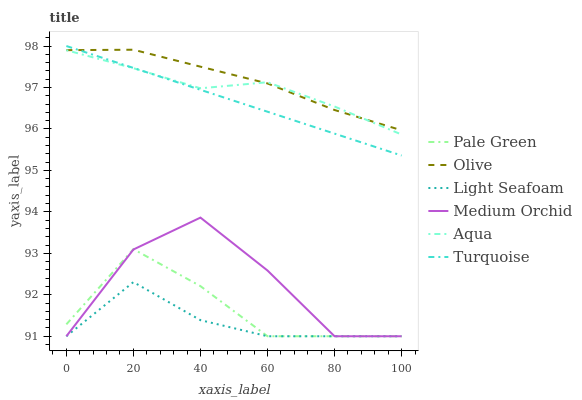Does Medium Orchid have the minimum area under the curve?
Answer yes or no. No. Does Medium Orchid have the maximum area under the curve?
Answer yes or no. No. Is Aqua the smoothest?
Answer yes or no. No. Is Aqua the roughest?
Answer yes or no. No. Does Aqua have the lowest value?
Answer yes or no. No. Does Medium Orchid have the highest value?
Answer yes or no. No. Is Pale Green less than Turquoise?
Answer yes or no. Yes. Is Turquoise greater than Light Seafoam?
Answer yes or no. Yes. Does Pale Green intersect Turquoise?
Answer yes or no. No. 